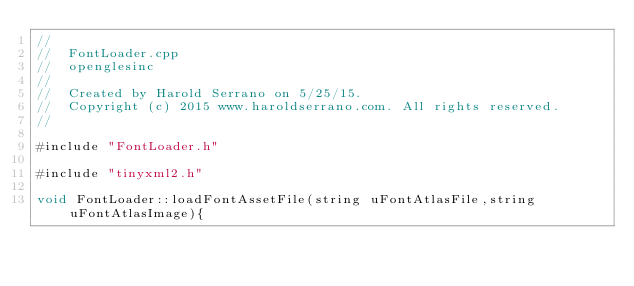<code> <loc_0><loc_0><loc_500><loc_500><_ObjectiveC_>//
//  FontLoader.cpp
//  openglesinc
//
//  Created by Harold Serrano on 5/25/15.
//  Copyright (c) 2015 www.haroldserrano.com. All rights reserved.
//

#include "FontLoader.h"

#include "tinyxml2.h"

void FontLoader::loadFontAssetFile(string uFontAtlasFile,string uFontAtlasImage){
    </code> 